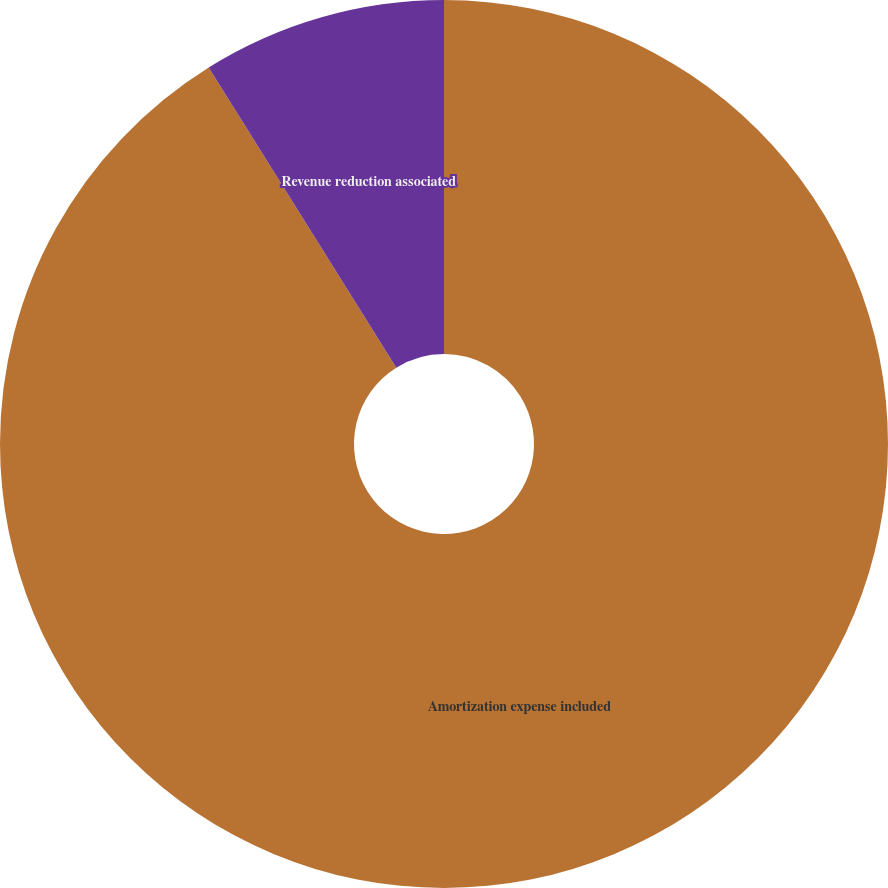<chart> <loc_0><loc_0><loc_500><loc_500><pie_chart><fcel>Amortization expense included<fcel>Revenue reduction associated<nl><fcel>91.11%<fcel>8.89%<nl></chart> 